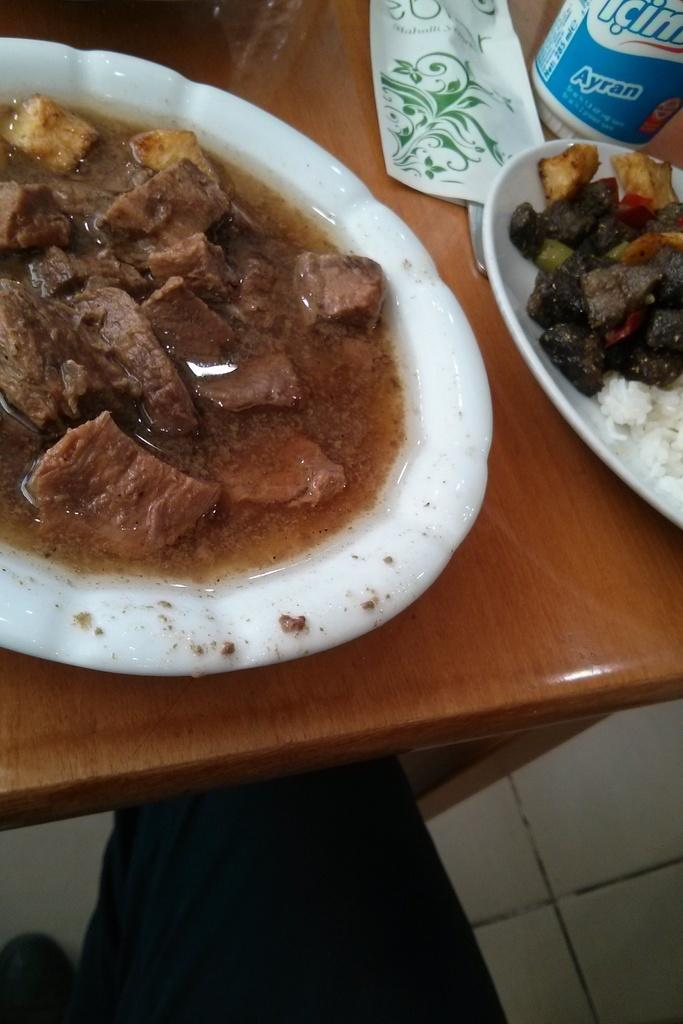What is on the plate in the image? There is food in the plate in the image. What type of food is in the bowl in the image? There is curry in a bowl in the image. What item is present for wiping or cleaning in the image? There is a napkin in the image. What object is on the table in the image? There is a bottle on the table in the image. Can you identify a human in the image? Yes, a human is visible in the image. Can you tell me how many bees are buzzing around the curry in the image? There are no bees present in the image; it only features food, curry, a napkin, a bottle, and a human. What topic is the human talking about in the image? The image does not provide any information about the conversation or topic being discussed by the human. 